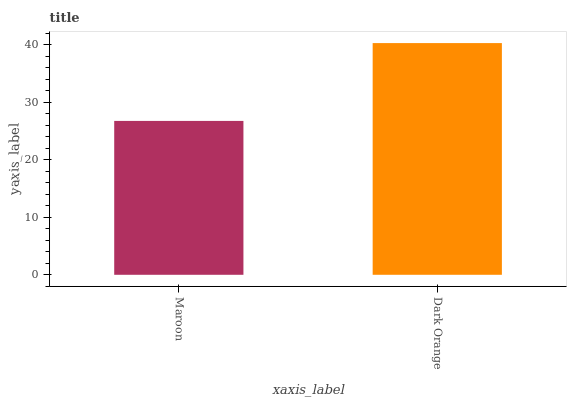Is Maroon the minimum?
Answer yes or no. Yes. Is Dark Orange the maximum?
Answer yes or no. Yes. Is Dark Orange the minimum?
Answer yes or no. No. Is Dark Orange greater than Maroon?
Answer yes or no. Yes. Is Maroon less than Dark Orange?
Answer yes or no. Yes. Is Maroon greater than Dark Orange?
Answer yes or no. No. Is Dark Orange less than Maroon?
Answer yes or no. No. Is Dark Orange the high median?
Answer yes or no. Yes. Is Maroon the low median?
Answer yes or no. Yes. Is Maroon the high median?
Answer yes or no. No. Is Dark Orange the low median?
Answer yes or no. No. 